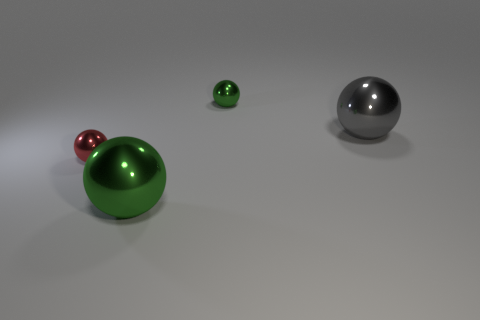How many green spheres must be subtracted to get 1 green spheres? 1 Subtract 2 balls. How many balls are left? 2 Subtract all large gray metal balls. How many balls are left? 3 Add 4 green metallic spheres. How many objects exist? 8 Subtract all gray balls. How many balls are left? 3 Subtract all brown balls. Subtract all purple cylinders. How many balls are left? 4 Add 3 small green metallic balls. How many small green metallic balls are left? 4 Add 1 small brown balls. How many small brown balls exist? 1 Subtract 0 yellow cylinders. How many objects are left? 4 Subtract all tiny blue matte balls. Subtract all large green spheres. How many objects are left? 3 